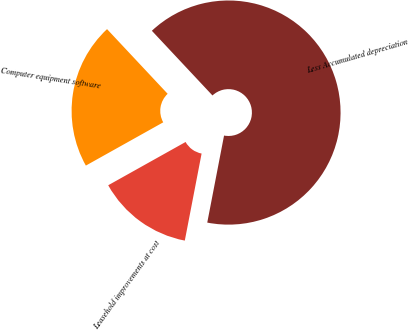Convert chart to OTSL. <chart><loc_0><loc_0><loc_500><loc_500><pie_chart><fcel>Computer equipment software<fcel>Leasehold improvements at cost<fcel>Less Accumulated depreciation<nl><fcel>21.13%<fcel>13.85%<fcel>65.01%<nl></chart> 